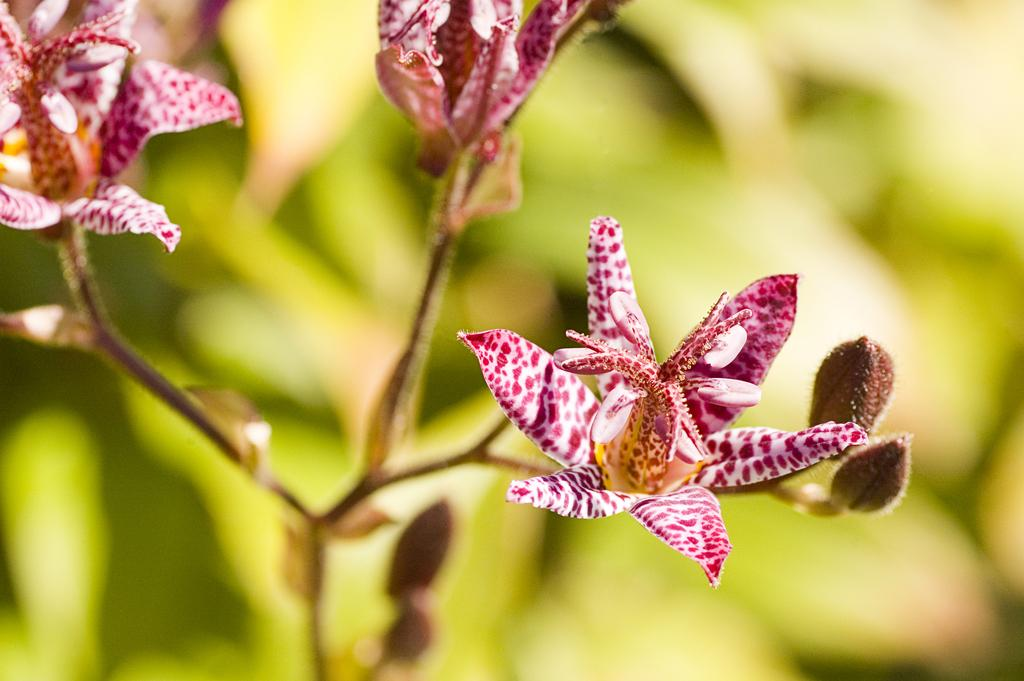Where was the image taken? The image was taken outdoors. What can be seen in the background of the image? There is a plant in the background of the image. How many flowers are on the plant in the middle of the image? There are three beautiful flowers on the plant in the middle of the image. What type of tin can be seen in the image? There is no tin present in the image. What is the connection between the flowers and the plant in the image? The flowers are growing on the plant, so they are connected by the plant's stem and roots. 